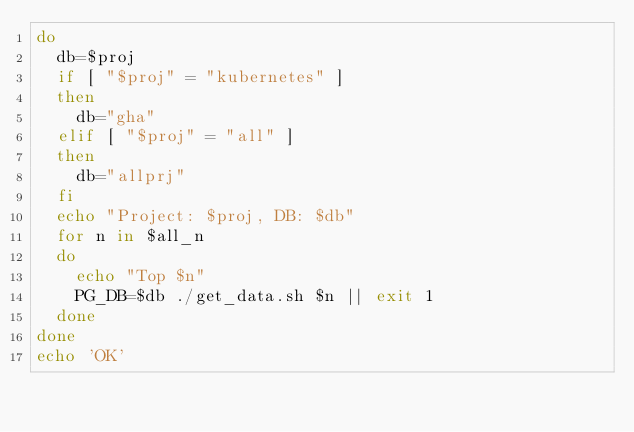<code> <loc_0><loc_0><loc_500><loc_500><_Bash_>do
  db=$proj
  if [ "$proj" = "kubernetes" ]
  then
    db="gha"
  elif [ "$proj" = "all" ]
  then
    db="allprj"
  fi
  echo "Project: $proj, DB: $db"
  for n in $all_n
  do
    echo "Top $n"
    PG_DB=$db ./get_data.sh $n || exit 1
  done
done
echo 'OK'
</code> 